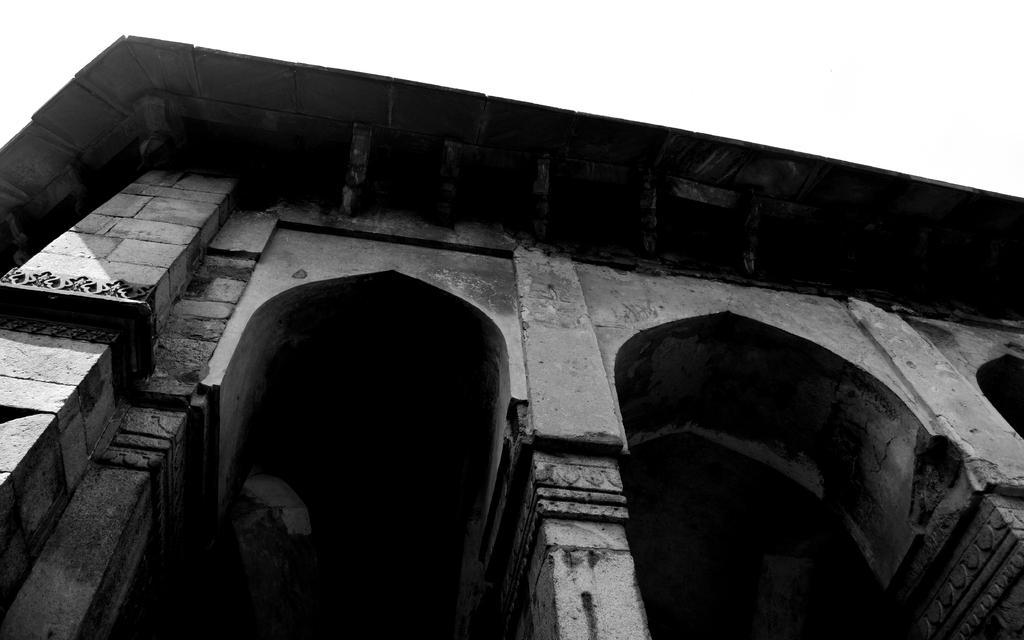What is the color scheme of the image? The image is black and white. What is the main subject in the image? There is a monument in the image. What else can be seen in the image besides the monument? The sky is visible in the image. Can you see any fog in the image? There is no fog visible in the image; it is a black and white image featuring a monument and the sky. 